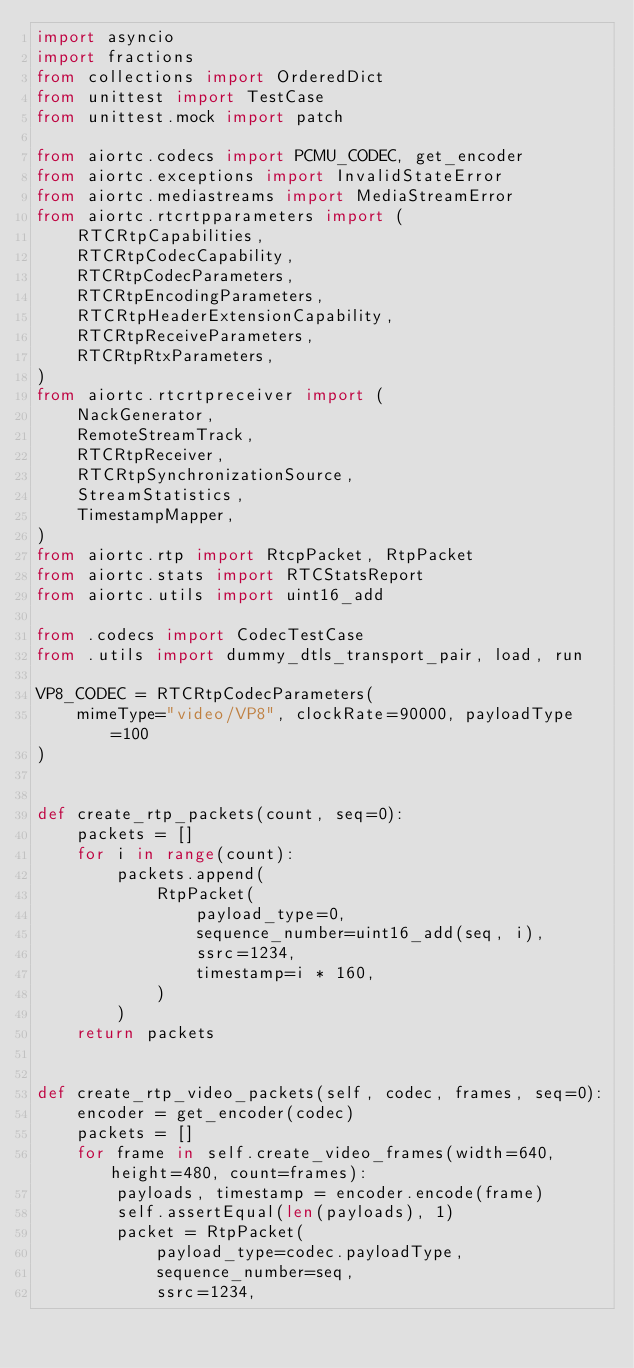Convert code to text. <code><loc_0><loc_0><loc_500><loc_500><_Python_>import asyncio
import fractions
from collections import OrderedDict
from unittest import TestCase
from unittest.mock import patch

from aiortc.codecs import PCMU_CODEC, get_encoder
from aiortc.exceptions import InvalidStateError
from aiortc.mediastreams import MediaStreamError
from aiortc.rtcrtpparameters import (
    RTCRtpCapabilities,
    RTCRtpCodecCapability,
    RTCRtpCodecParameters,
    RTCRtpEncodingParameters,
    RTCRtpHeaderExtensionCapability,
    RTCRtpReceiveParameters,
    RTCRtpRtxParameters,
)
from aiortc.rtcrtpreceiver import (
    NackGenerator,
    RemoteStreamTrack,
    RTCRtpReceiver,
    RTCRtpSynchronizationSource,
    StreamStatistics,
    TimestampMapper,
)
from aiortc.rtp import RtcpPacket, RtpPacket
from aiortc.stats import RTCStatsReport
from aiortc.utils import uint16_add

from .codecs import CodecTestCase
from .utils import dummy_dtls_transport_pair, load, run

VP8_CODEC = RTCRtpCodecParameters(
    mimeType="video/VP8", clockRate=90000, payloadType=100
)


def create_rtp_packets(count, seq=0):
    packets = []
    for i in range(count):
        packets.append(
            RtpPacket(
                payload_type=0,
                sequence_number=uint16_add(seq, i),
                ssrc=1234,
                timestamp=i * 160,
            )
        )
    return packets


def create_rtp_video_packets(self, codec, frames, seq=0):
    encoder = get_encoder(codec)
    packets = []
    for frame in self.create_video_frames(width=640, height=480, count=frames):
        payloads, timestamp = encoder.encode(frame)
        self.assertEqual(len(payloads), 1)
        packet = RtpPacket(
            payload_type=codec.payloadType,
            sequence_number=seq,
            ssrc=1234,</code> 